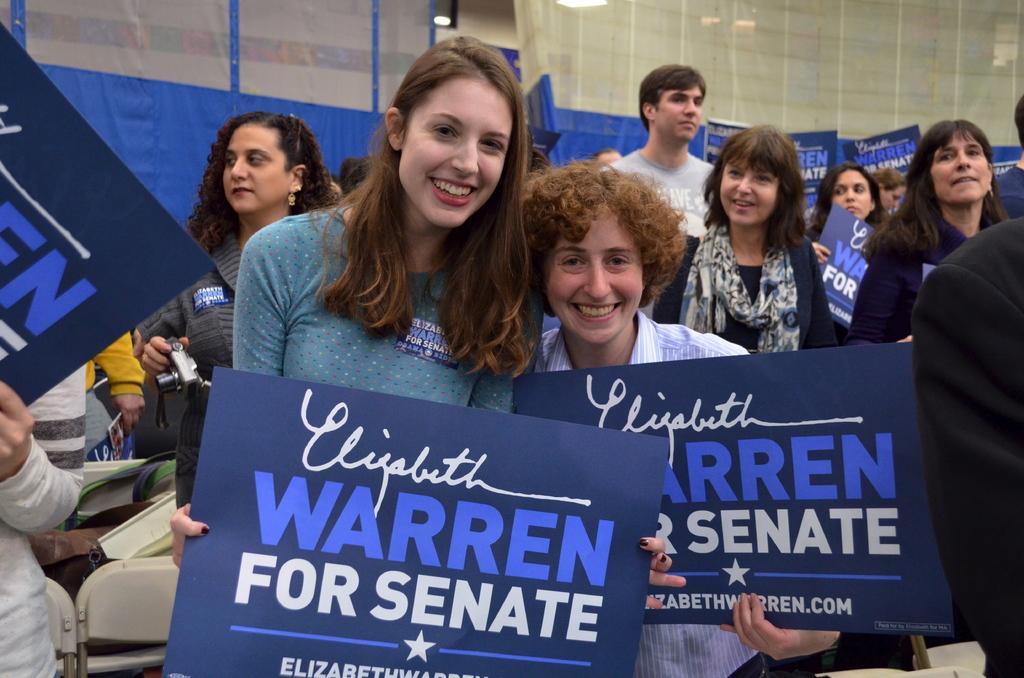Could you give a brief overview of what you see in this image? In this image, there are a few people. Among them, some people are holding some objects. We can see some posters with text. We can see the wall and some lights. We can see some chairs. 